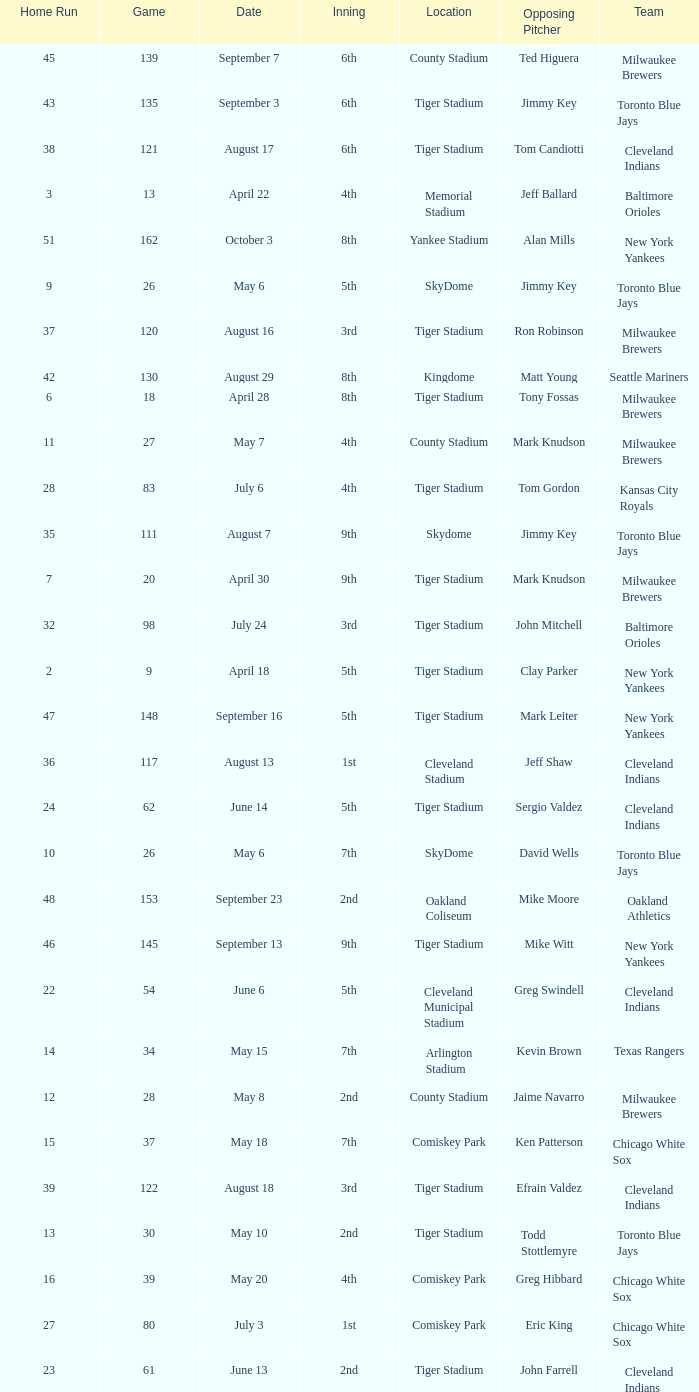On June 17 in Tiger stadium, what was the average home run? 25.0. 